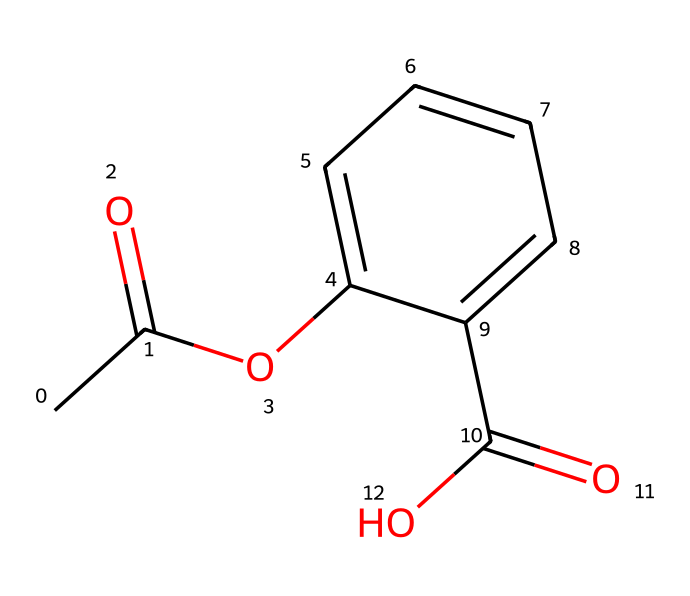What is the molecular formula of aspirin? The SMILES representation can be translated into its molecular formula by identifying the atoms and their counts. The structure includes 9 Carbon (C) atoms, 8 Hydrogen (H) atoms, and 4 Oxygen (O) atoms. Combining these, the molecular formula is C9H8O4.
Answer: C9H8O4 How many rings are present in the structure of aspirin? By analyzing the SMILES representation, the chemical structure contains one ring (the benzene ring), which is represented by the letters and numbers indicating that it's a cyclic structure.
Answer: 1 What functional group is represented by the -COOH part of the aspirin molecule? The -COOH part indicates a carboxylic acid functional group, which can be identified in the structure where a carbon is double bonded to an oxygen and single bonded to a hydroxyl group.
Answer: carboxylic acid What is the common use of aspirin in medicine? The primary application of aspirin is as a pain reliever and anti-inflammatory medication. It is widely used to reduce pain, fever, and inflammation, and it also has a role in heart health, as it can reduce the risk of heart attacks.
Answer: analgesic Why is aspirin classified as a non-steroidal anti-inflammatory drug (NSAID)? Aspirin is classified as a NSAID because it reduces inflammation through the inhibition of cyclooxygenase (COX) enzymes, which are involved in the synthesis of prostaglandins that mediate inflammation and pain. This action distinguishes it from corticosteroids but still provides anti-inflammatory effects.
Answer: inhibits COX enzymes 